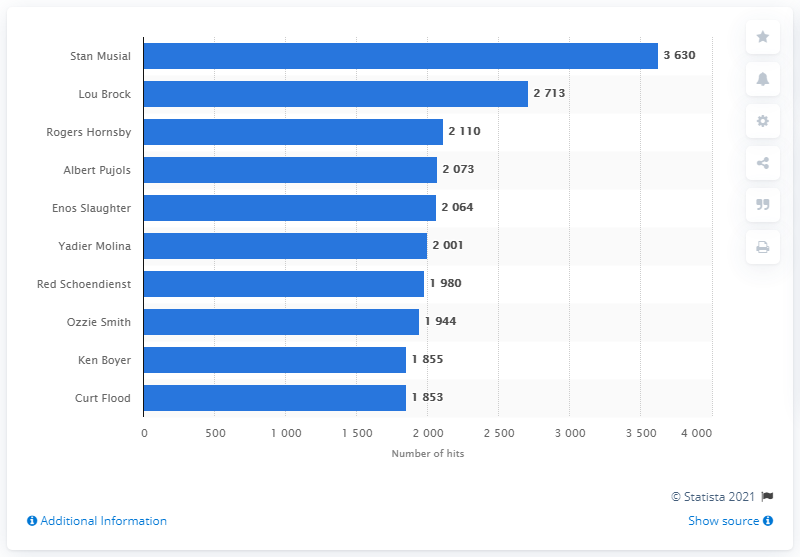Give some essential details in this illustration. Stan Musial holds the record for the most hits in the history of the St. Louis Cardinals franchise. 